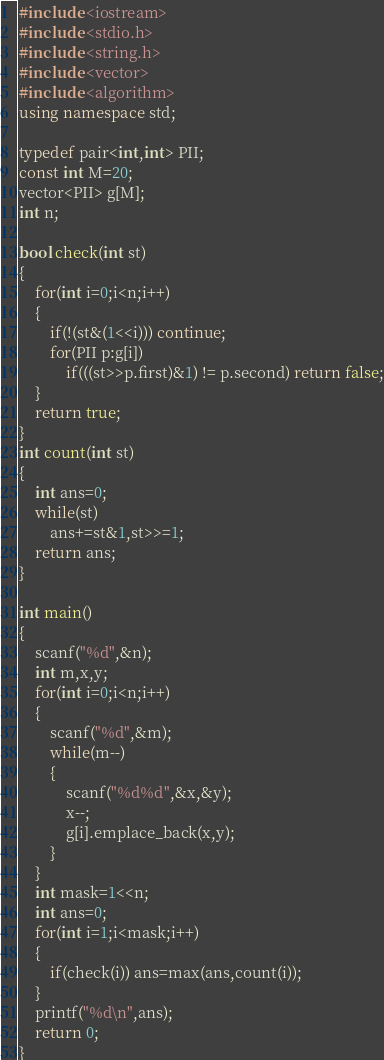Convert code to text. <code><loc_0><loc_0><loc_500><loc_500><_C++_>#include <iostream>
#include <stdio.h>
#include <string.h>
#include <vector>
#include <algorithm>
using namespace std;

typedef pair<int,int> PII;
const int M=20;
vector<PII> g[M];
int n;

bool check(int st)
{
	for(int i=0;i<n;i++)
	{
		if(!(st&(1<<i))) continue;
		for(PII p:g[i])
			if(((st>>p.first)&1) != p.second) return false;
	}
	return true;
}
int count(int st)
{
	int ans=0;
	while(st)
		ans+=st&1,st>>=1;
	return ans;
}

int main()
{
	scanf("%d",&n);
	int m,x,y;
	for(int i=0;i<n;i++)
	{
		scanf("%d",&m);
		while(m--)
		{
			scanf("%d%d",&x,&y);
			x--;
			g[i].emplace_back(x,y);
		}
	}
	int mask=1<<n;
	int ans=0;
	for(int i=1;i<mask;i++)
	{
		if(check(i)) ans=max(ans,count(i));
	}
	printf("%d\n",ans);
	return 0;
}</code> 